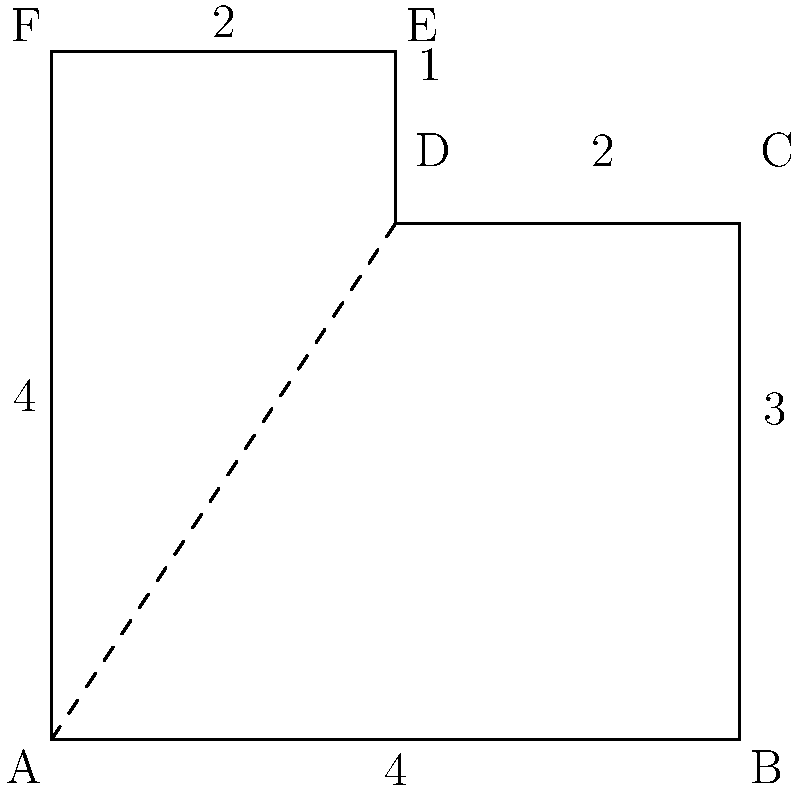As a Minecraft server owner, you're designing a custom skin template. The template is shaped like the polygon shown above, with dimensions in pixels. Calculate the total area of this skin template in square pixels. To calculate the area of this custom Minecraft skin template, we need to break it down into simpler shapes and add their areas together.

1. The template can be divided into a rectangle (ABCF) and a smaller rectangle (CDEF).

2. Area of rectangle ABCF:
   $A_{ABCF} = 4 \times 3 = 12$ square pixels

3. Area of rectangle CDEF:
   $A_{CDEF} = 2 \times 1 = 2$ square pixels

4. Total area:
   $A_{total} = A_{ABCF} + A_{CDEF} = 12 + 2 = 14$ square pixels

Therefore, the total area of the custom Minecraft skin template is 14 square pixels.
Answer: 14 square pixels 